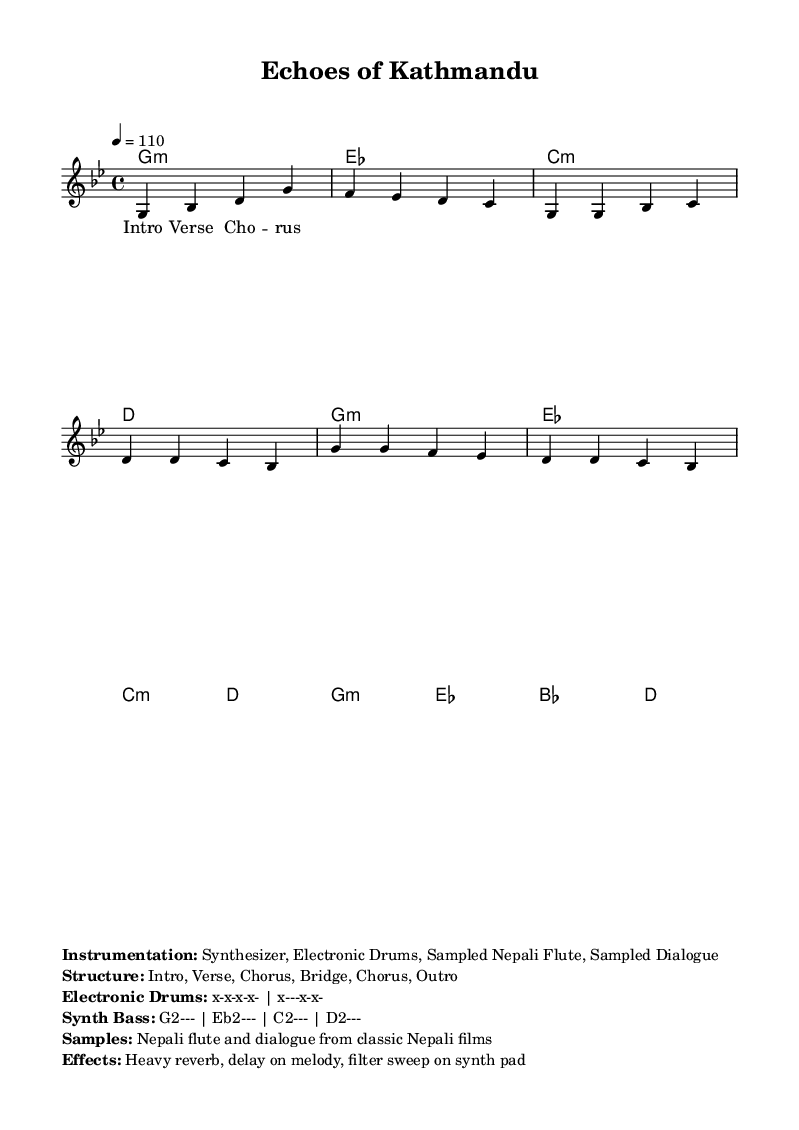What is the key signature of this music? The key signature is G minor, which has two flats: B flat and E flat. This is indicated at the beginning of the score after the clef.
Answer: G minor What is the time signature of this music? The time signature is 4/4, which means there are four beats per measure and the quarter note equals one beat. This is shown at the beginning of the score next to the key signature.
Answer: 4/4 What is the tempo marking? The tempo marking is 110 beats per minute, indicating the speed at which the piece should be played. This is specified in the score as "4 = 110" under the tempo section.
Answer: 110 What instruments are used in this composition? The instrumentation includes a synthesizer, electronic drums, sampled Nepali flute, and sampled dialogue. These details are listed in the markup section below the score.
Answer: Synthesizer, Electronic Drums, Sampled Nepali Flute, Sampled Dialogue What is the structure of the piece? The structure consists of an Intro, Verse, Chorus, Bridge, Chorus, and Outro. This is stated in the markup under the instrumentation list, outlining the sections of the music.
Answer: Intro, Verse, Chorus, Bridge, Chorus, Outro How many parts are there in the verse? The verse is indicated as having one part in the sheet music due to space constraints, which means only part of the verse has been shown in the score. The first part of the verse music is presented.
Answer: One part What type of effects are applied to the melody? The effects include heavy reverb and delay on the melody, as well as a filter sweep on the synth pad. These effects are noted in the markup section, discussing the production aspects of the piece.
Answer: Heavy reverb, delay 